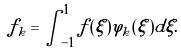<formula> <loc_0><loc_0><loc_500><loc_500>f _ { k } = \int _ { - 1 } ^ { 1 } f ( \xi ) \varphi _ { k } ( \xi ) d \xi .</formula> 